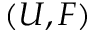<formula> <loc_0><loc_0><loc_500><loc_500>( U , F )</formula> 